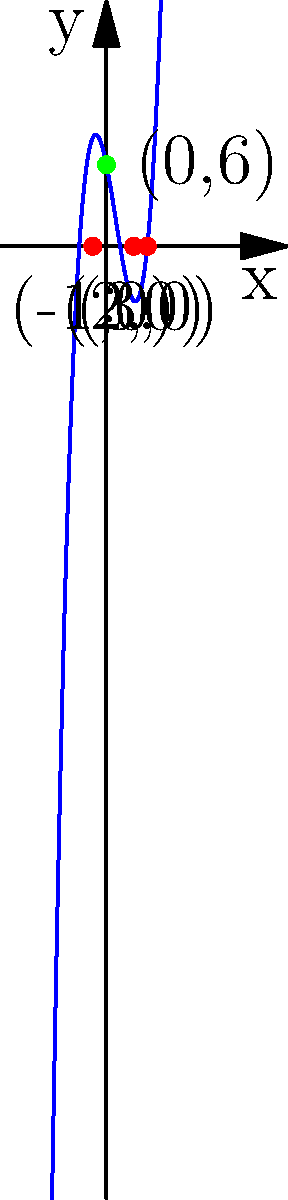Given the polynomial graph above, which represents a Ruby method for calculating $f(x) = x^3 - 2x^2 - 5x + 6$, determine the x-intercepts and y-intercept. How might you use Resque to parallelize the calculation of these intercepts for multiple polynomials? Let's approach this step-by-step:

1) X-intercepts:
   X-intercepts are the points where the graph crosses the x-axis (y = 0).
   From the graph, we can see three x-intercepts:
   $(-1, 0)$, $(2, 0)$, and $(3, 0)$

2) Y-intercept:
   The y-intercept is the point where the graph crosses the y-axis (x = 0).
   From the graph, we can see the y-intercept is at $(0, 6)$

3) Verification using the polynomial function:
   $f(x) = x^3 - 2x^2 - 5x + 6$
   
   For x-intercepts:
   $f(-1) = (-1)^3 - 2(-1)^2 - 5(-1) + 6 = -1 - 2 + 5 + 6 = 8 - 8 = 0$
   $f(2) = (2)^3 - 2(2)^2 - 5(2) + 6 = 8 - 8 - 10 + 6 = -4 + 4 = 0$
   $f(3) = (3)^3 - 2(3)^2 - 5(3) + 6 = 27 - 18 - 15 + 6 = 0$

   For y-intercept:
   $f(0) = (0)^3 - 2(0)^2 - 5(0) + 6 = 6$

4) Using Resque for parallelization:
   To parallelize the calculation of intercepts for multiple polynomials using Resque:

   a) Create a Ruby class that calculates intercepts for a given polynomial.
   b) Enqueue jobs for each polynomial using Resque.enqueue.
   c) Process these jobs in parallel on multiple worker instances.
   d) Collect and aggregate results from all workers.

This approach would significantly speed up the calculation process for large sets of polynomials.
Answer: X-intercepts: (-1,0), (2,0), (3,0); Y-intercept: (0,6) 